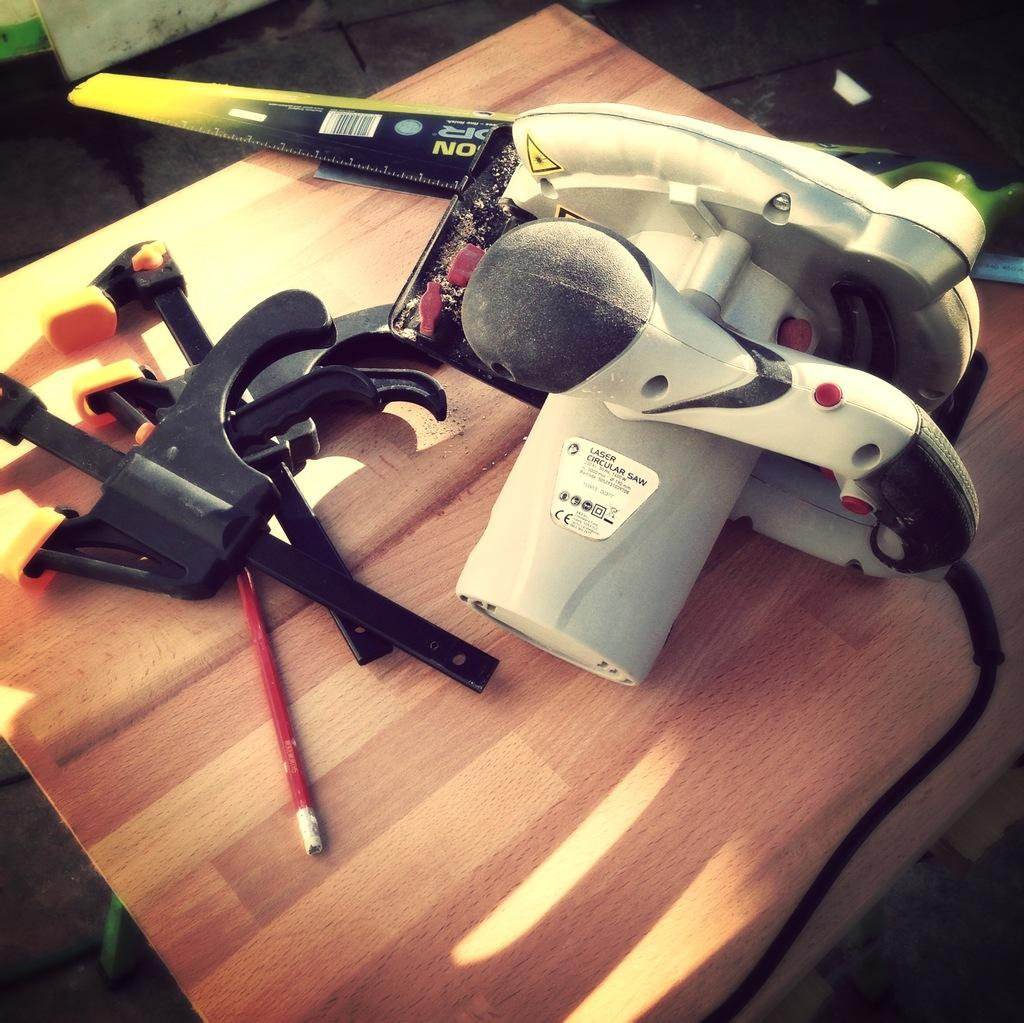What is the color of the surface on which the objects are placed in the image? The surface is brown in color. What type of items can be seen on the surface? There are stickers in the image. Can you describe the stickers in more detail? Yes, there is writing on the stickers. Where is the sink located in the image? There is no sink present in the image. What type of vehicle is parked next to the objects on the brown surface? There is no vehicle, such as a van, present in the image. 